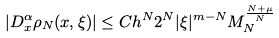<formula> <loc_0><loc_0><loc_500><loc_500>\left | D _ { x } ^ { \alpha } \rho _ { N } ( x , \xi ) \right | \leq C h ^ { N } 2 ^ { N } | \xi | ^ { m - N } M _ { N } ^ { \frac { N + \mu } { N } }</formula> 